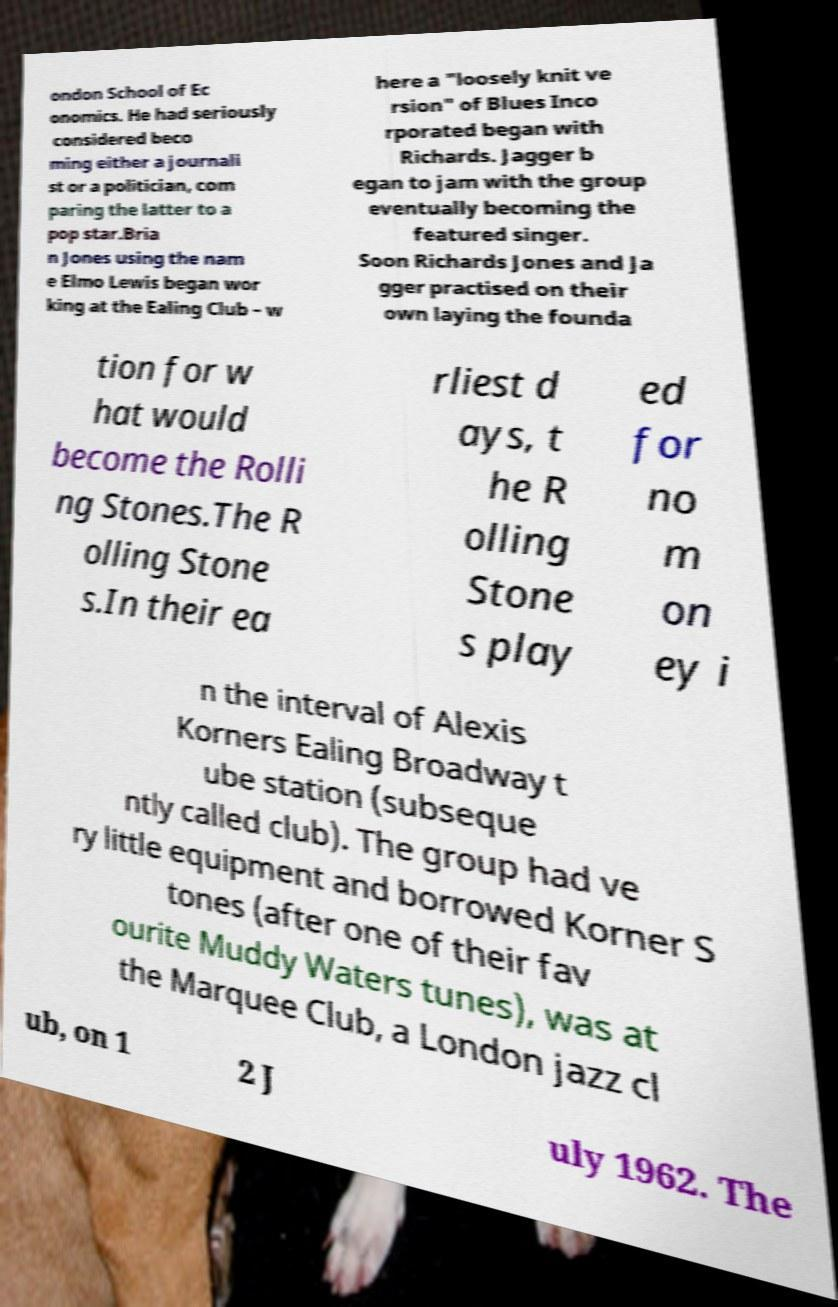Could you extract and type out the text from this image? ondon School of Ec onomics. He had seriously considered beco ming either a journali st or a politician, com paring the latter to a pop star.Bria n Jones using the nam e Elmo Lewis began wor king at the Ealing Club – w here a "loosely knit ve rsion" of Blues Inco rporated began with Richards. Jagger b egan to jam with the group eventually becoming the featured singer. Soon Richards Jones and Ja gger practised on their own laying the founda tion for w hat would become the Rolli ng Stones.The R olling Stone s.In their ea rliest d ays, t he R olling Stone s play ed for no m on ey i n the interval of Alexis Korners Ealing Broadway t ube station (subseque ntly called club). The group had ve ry little equipment and borrowed Korner S tones (after one of their fav ourite Muddy Waters tunes), was at the Marquee Club, a London jazz cl ub, on 1 2 J uly 1962. The 